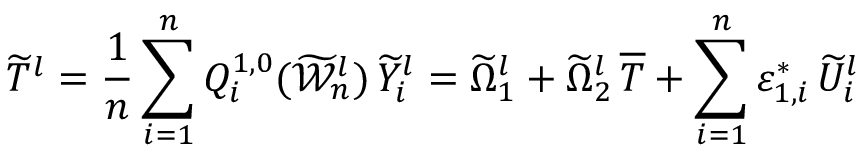<formula> <loc_0><loc_0><loc_500><loc_500>\widetilde { T } ^ { l } = \frac { 1 } { n } \sum _ { i = 1 } ^ { n } Q _ { i } ^ { 1 , 0 } ( \widetilde { \mathcal { W } } _ { n } ^ { l } ) \, \widetilde { Y } _ { i } ^ { l } = \widetilde { \Omega } _ { 1 } ^ { l } + \widetilde { \Omega } _ { 2 } ^ { l } \, \overline { T } + \sum _ { i = 1 } ^ { n } \varepsilon _ { 1 , i } ^ { * } \, \widetilde { U } _ { i } ^ { l }</formula> 